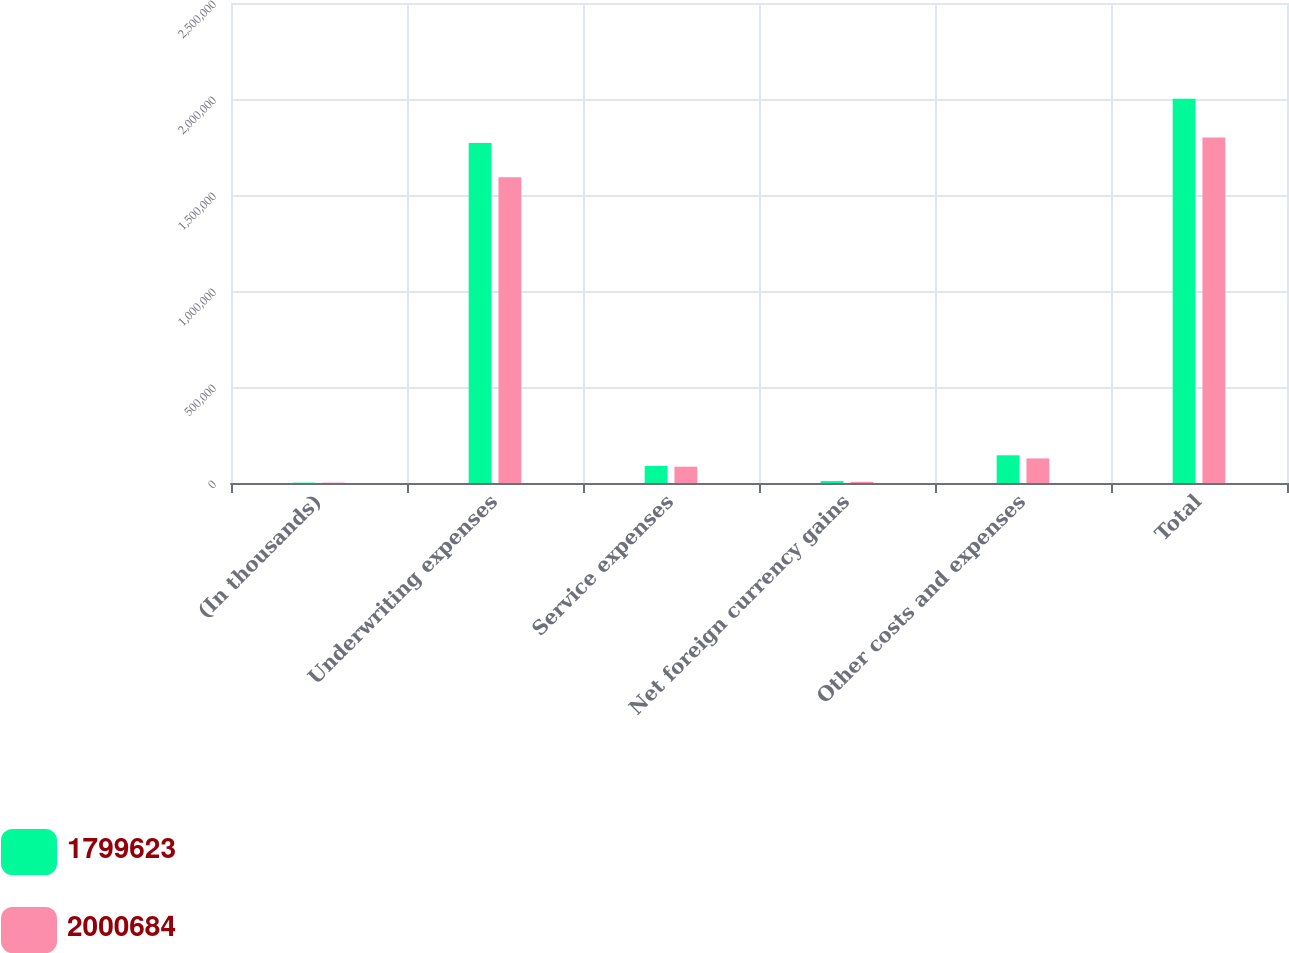<chart> <loc_0><loc_0><loc_500><loc_500><stacked_bar_chart><ecel><fcel>(In thousands)<fcel>Underwriting expenses<fcel>Service expenses<fcel>Net foreign currency gains<fcel>Other costs and expenses<fcel>Total<nl><fcel>1.79962e+06<fcel>2013<fcel>1.77113e+06<fcel>88662<fcel>10120<fcel>144305<fcel>2.00068e+06<nl><fcel>2.00068e+06<fcel>2012<fcel>1.59275e+06<fcel>84986<fcel>6092<fcel>127983<fcel>1.79962e+06<nl></chart> 